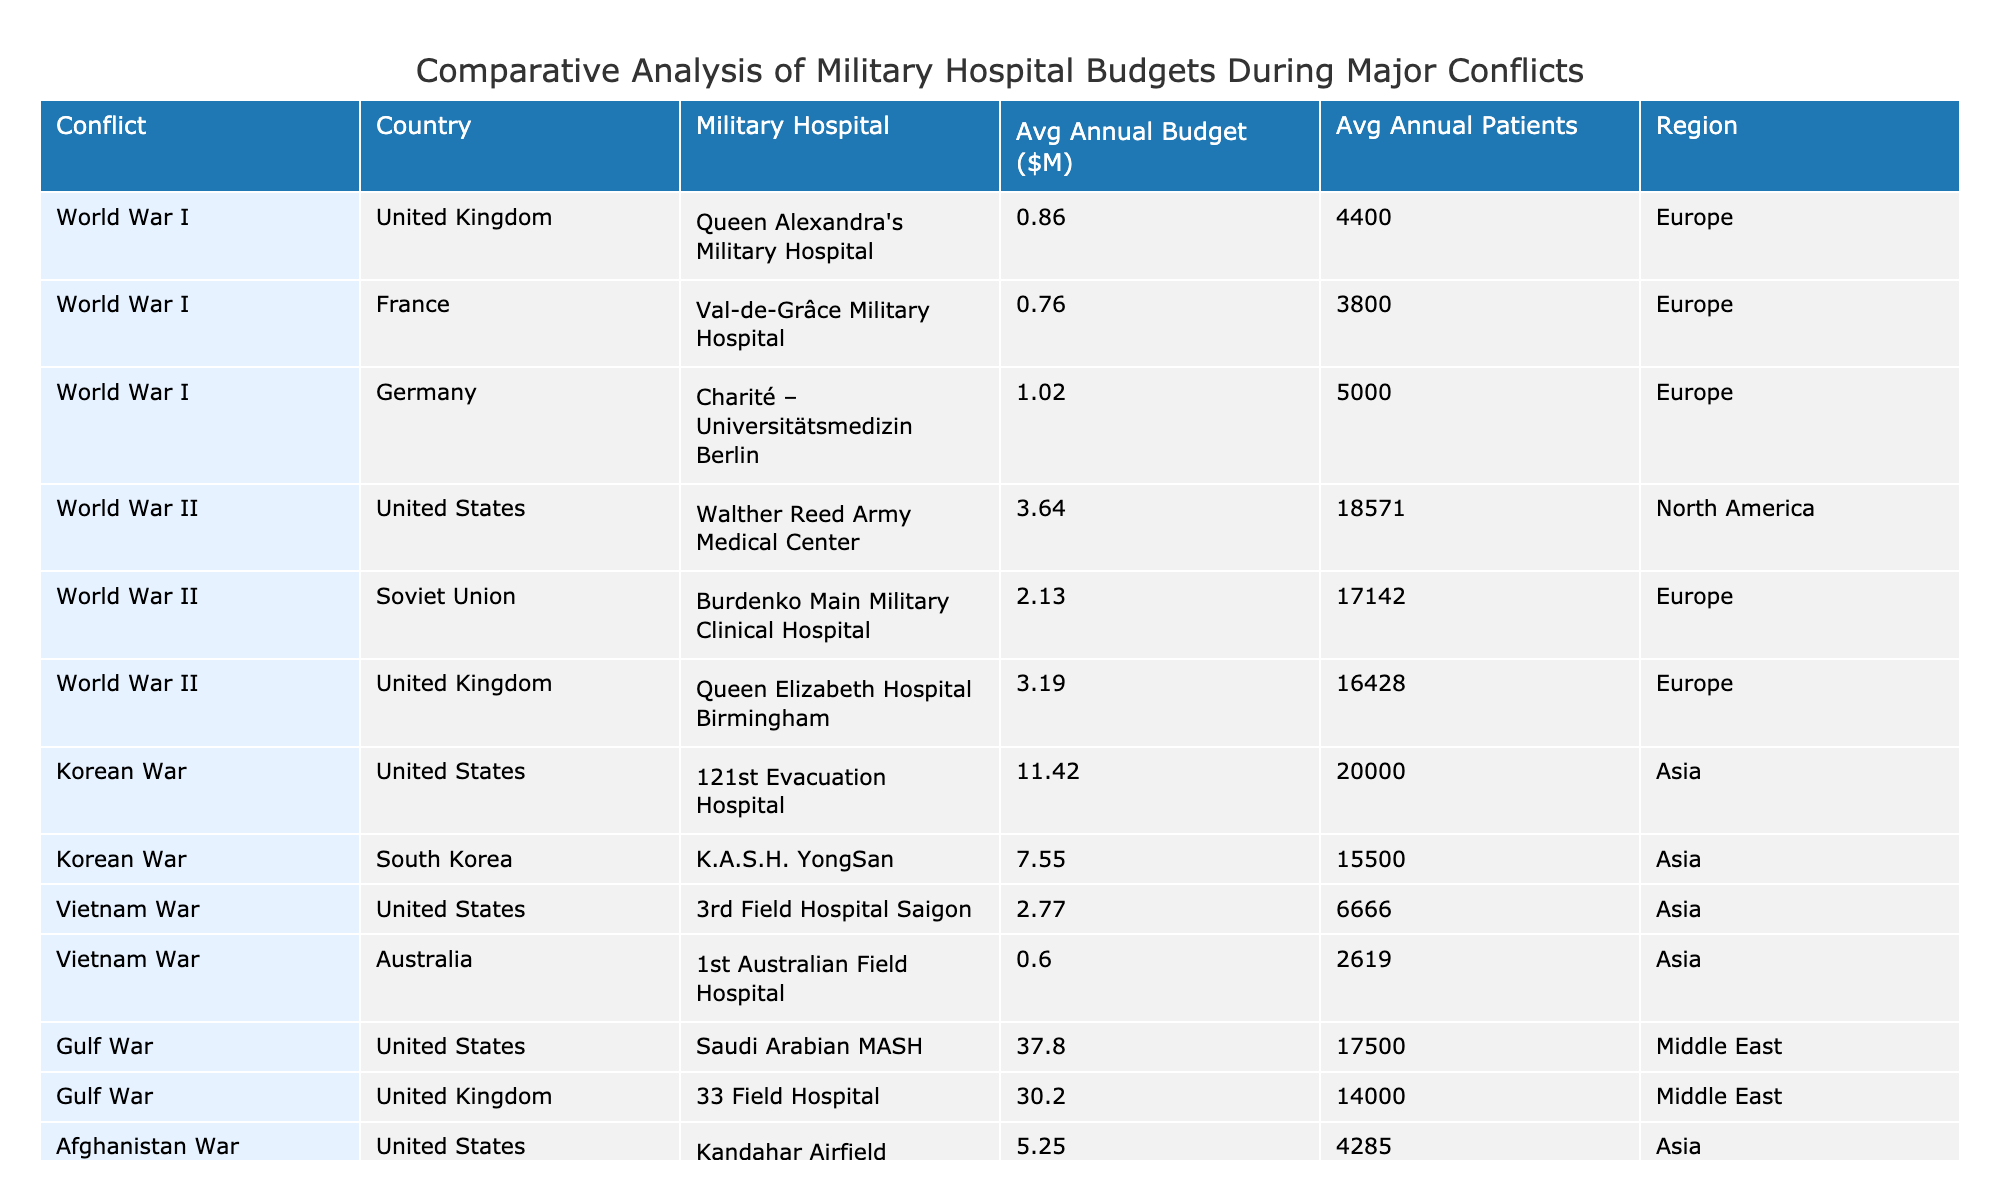What is the average annual budget for hospitals during World War II? First, we list the annual budgets for military hospitals during World War II: 25.5, 14.9, and 22.3 million USD. Next, we find the average by summing these values: 25.5 + 14.9 + 22.3 = 62.7 million USD. Then we divide by the number of hospitals (3): 62.7 / 3 = 20.9 million USD.
Answer: 20.9 million USD Which country had the highest total patients treated during the conflicts listed? By reviewing the total patients treated for each entry, we find the highest values: 130,000 (United States, World War II), 120,000 (Soviet Union, World War II), and 140,000 (United States, Vietnam War). The highest is from the United States during the Vietnam War with 140,000 patients treated.
Answer: United States (Vietnam War) Did the United Kingdom have a military hospital with a budget greater than 20 million USD in the Gulf War? In the Gulf War, the UK military hospital listed has a budget of 60.4 million USD. Since this is greater than 20 million USD, the answer is yes.
Answer: Yes What is the difference in average annual budget between the military hospitals in World War I and World War II? For World War I, the average annual budgets were: 4.3, 3.8, and 5.1 million USD. The average is (4.3 + 3.8 + 5.1) / 3 = 4.4 million USD. For World War II, the average was calculated as (25.5 + 14.9 + 22.3) / 3 = 20.9 million USD. The difference is 20.9 - 4.4 = 16.5 million USD.
Answer: 16.5 million USD Which military hospital had the lowest average annual budget, and what was that budget? By examining average annual budgets across the hospitals, the lowest budget is 4.3 million USD for Queen Alexandra's Military Hospital during World War I.
Answer: Queen Alexandra's Military Hospital, 4.3 million USD How many total patients did the US military hospitals treat during the Korean War? The US military hospital during the Korean War treated 80,000 patients. There is only one US hospital included for this conflict, so the total is simply 80,000 patients.
Answer: 80,000 patients What region had the highest average annual budget for military hospitals? We list the average annual budgets for each region: Asia (average from Korean War and Vietnam War entries) yielding significant values, North America (World War II has 20.9 million), Europe (averages out from multiple entries), and Middle East (Gulf War entries). After calculations, Asia has the highest average due to high budgets from the Vietnam War.
Answer: Asia Is the average annual patient count higher in the Vietnam War than in the Gulf War? For the Vietnam War, the average annual patients treated from one US hospital is 140,000, while the Gulf War has 35,000 treated at one US hospital and 28,000 at the UK hospital. The composite average is (35,000 + 28,000) / 2 = 31,500. Since 140,000 is greater than 31,500, the answer is yes.
Answer: Yes 